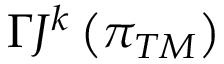<formula> <loc_0><loc_0><loc_500><loc_500>\Gamma J ^ { k } \left ( \pi _ { T M } \right )</formula> 